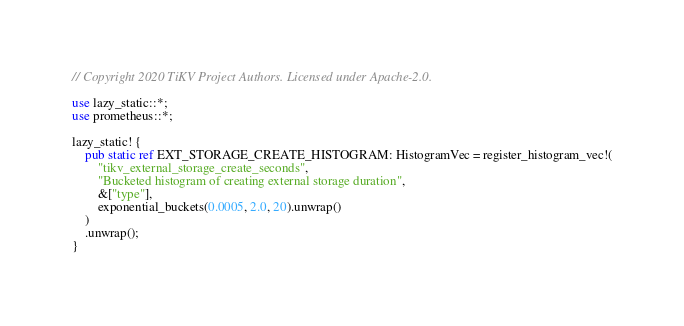Convert code to text. <code><loc_0><loc_0><loc_500><loc_500><_Rust_>// Copyright 2020 TiKV Project Authors. Licensed under Apache-2.0.

use lazy_static::*;
use prometheus::*;

lazy_static! {
    pub static ref EXT_STORAGE_CREATE_HISTOGRAM: HistogramVec = register_histogram_vec!(
        "tikv_external_storage_create_seconds",
        "Bucketed histogram of creating external storage duration",
        &["type"],
        exponential_buckets(0.0005, 2.0, 20).unwrap()
    )
    .unwrap();
}
</code> 